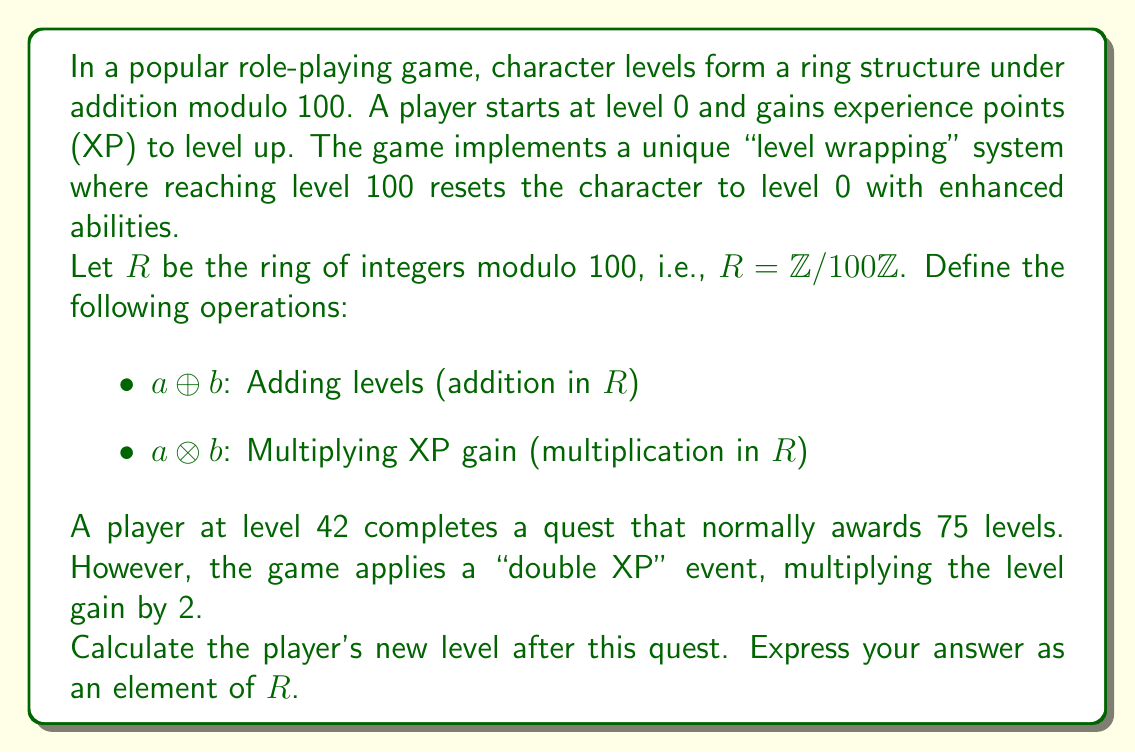What is the answer to this math problem? Let's approach this step-by-step using ring theory:

1) First, we need to calculate the level gain from the quest:
   $75 \otimes 2 = 150 \pmod{100} = 50$

   This is because in $R$, multiplication by 2 is equivalent to doubling and then taking the result modulo 100.

2) Now, we need to add this level gain to the player's current level:
   $42 \oplus 50 = 92 \pmod{100}$

   In $R$, addition is performed modulo 100, so we simply add and take the result modulo 100.

3) The final level is therefore 92.

This problem demonstrates how ring theory can model the cyclical nature of levels in this game:

- The additive identity (0) represents a new character.
- The multiplicative identity (1) represents no change in XP gain.
- The modular arithmetic naturally handles the "level wrapping" at 100.
- Addition in the ring models level gains.
- Multiplication in the ring models XP multipliers.

This ring structure ensures that all level calculations remain within the game's defined level range (0-99), no matter how much XP is gained or how it's multiplied.
Answer: 92 